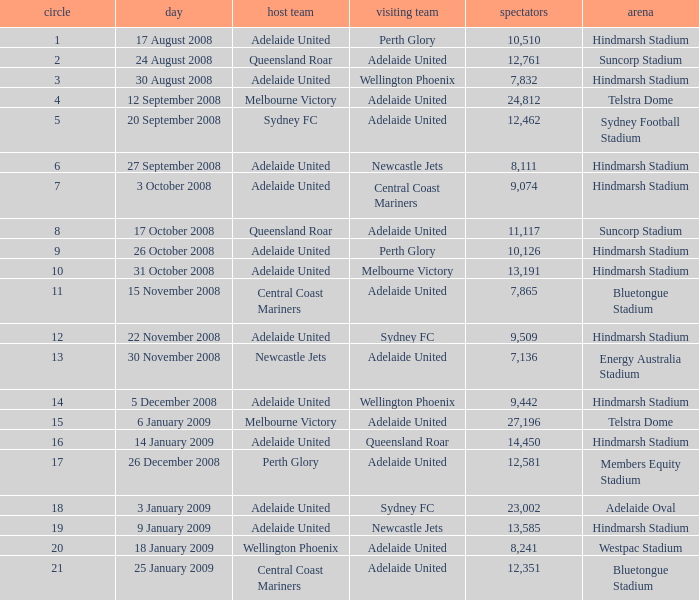What is the round when 11,117 people attended the game on 26 October 2008? 9.0. 